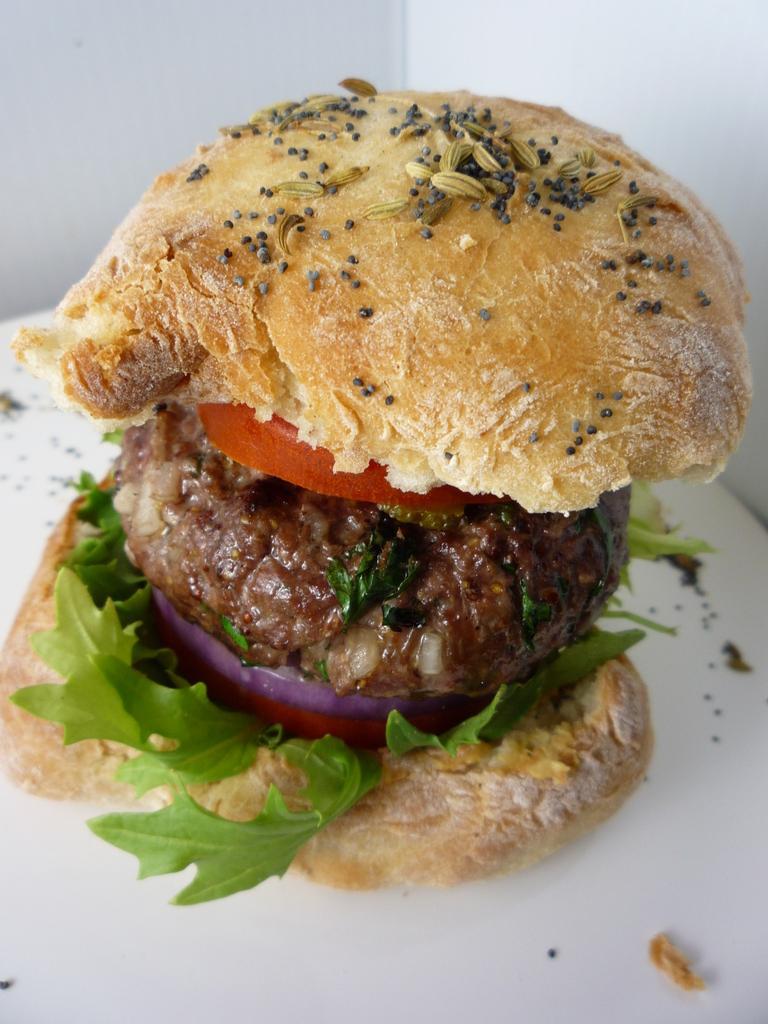Describe this image in one or two sentences. In the center of the image we can see one table. On the table, we can see one burger, in which we can see breads, leafy vegetables, tomato slices, onion slices and some food item. In the background there is a wall. 